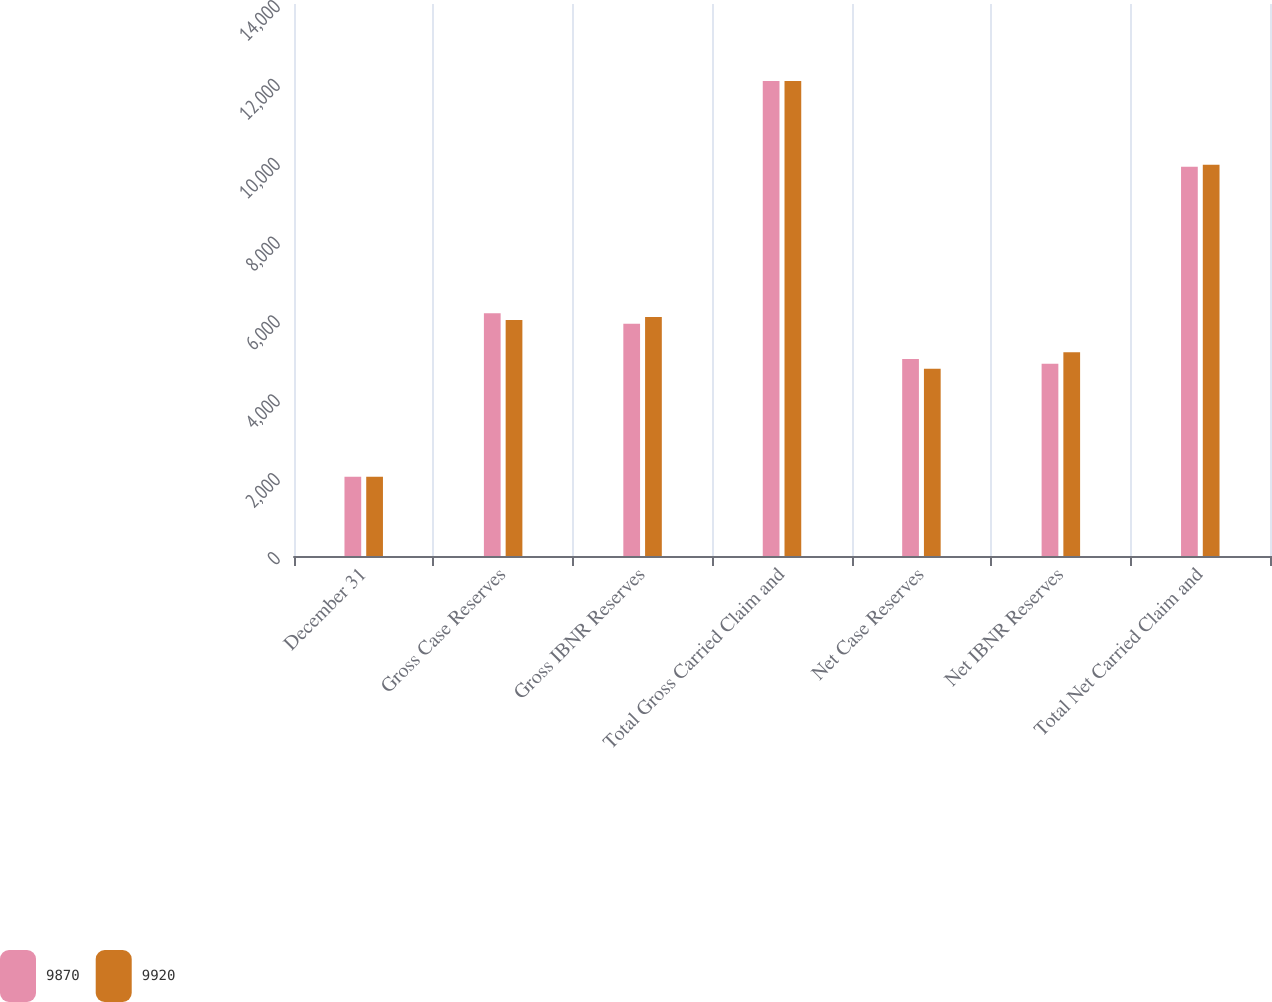<chart> <loc_0><loc_0><loc_500><loc_500><stacked_bar_chart><ecel><fcel>December 31<fcel>Gross Case Reserves<fcel>Gross IBNR Reserves<fcel>Total Gross Carried Claim and<fcel>Net Case Reserves<fcel>Net IBNR Reserves<fcel>Total Net Carried Claim and<nl><fcel>9870<fcel>2008<fcel>6158<fcel>5890<fcel>12048<fcel>4995<fcel>4875<fcel>9870<nl><fcel>9920<fcel>2007<fcel>5988<fcel>6060<fcel>12048<fcel>4750<fcel>5170<fcel>9920<nl></chart> 